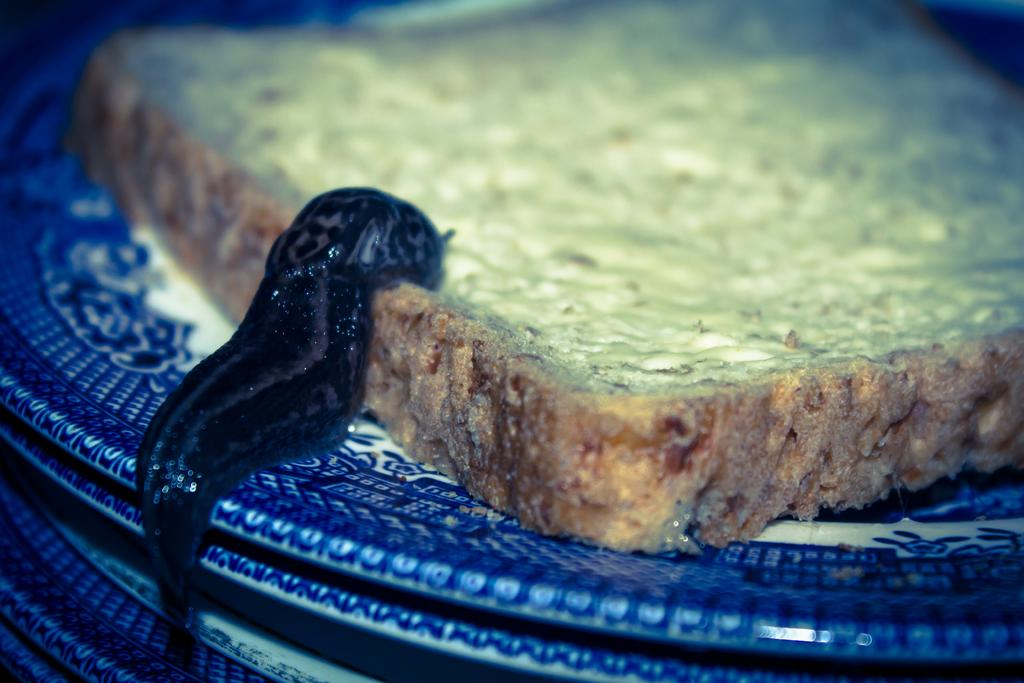What color can be seen on some objects in the image? There are blue color things in the image. What type of food is present in the image? There is a bread in the image. What color is the other prominent object in the image? There is a black color thing in the image. How does the visitor interact with the knowledge in the image? There is no visitor or knowledge present in the image. What type of silver object can be seen in the image? There is no silver object present in the image. 